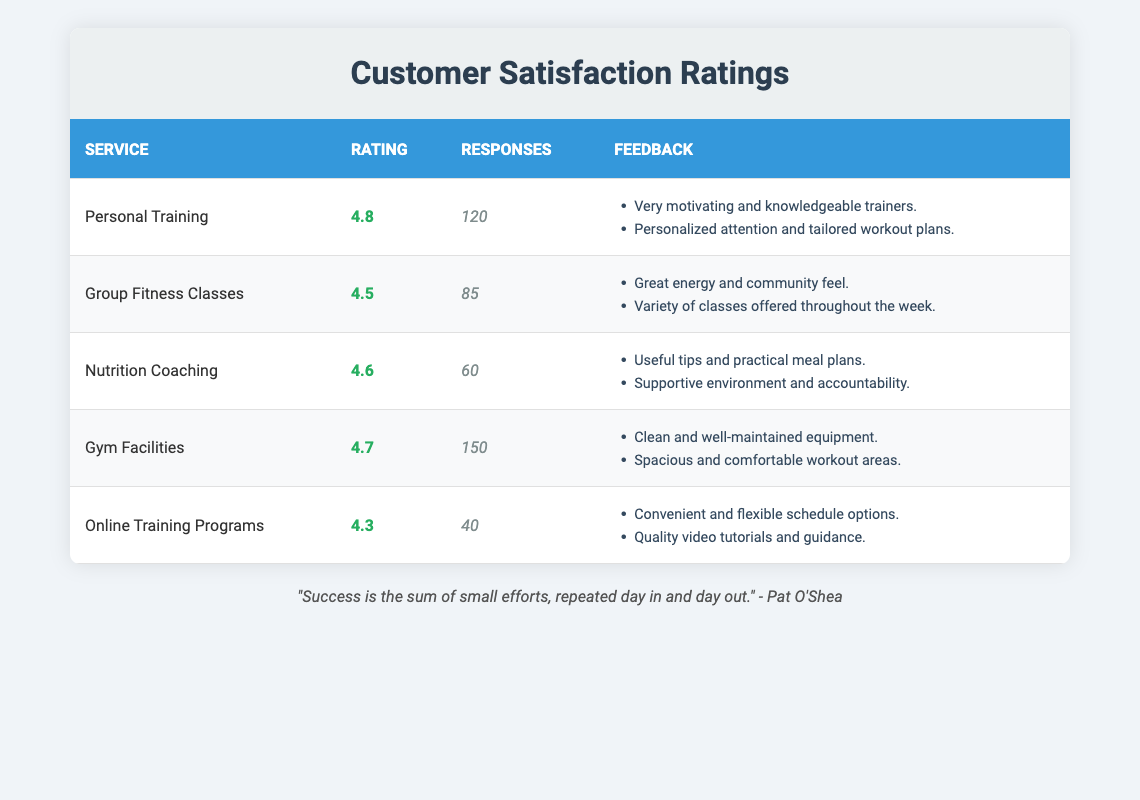What is the highest customer satisfaction rating among the services? By reviewing the ratings column, we see Personal Training with a rating of 4.8 is the highest one listed.
Answer: 4.8 How many responses were received for Group Fitness Classes? Looking at the responses column for Group Fitness Classes, it shows a total of 85 responses were received.
Answer: 85 Are there more responses for Gym Facilities than Personal Training? Gym Facilities received 150 responses while Personal Training received 120 responses. Since 150 is greater than 120, the answer is yes.
Answer: Yes What is the average rating of Nutrition Coaching and Online Training Programs? The rating for Nutrition Coaching is 4.6 and for Online Training Programs is 4.3. Adding these two gives 4.6 + 4.3 = 8.9. Dividing by 2 for the average gives 8.9 / 2 = 4.45.
Answer: 4.45 Did the feedback for Gym Facilities mention anything about equipment? Yes, the feedback for Gym Facilities includes the comment "Clean and well-maintained equipment." thus confirming that it was mentioned.
Answer: Yes How many total responses were received across all services? By summing all the responses: 120 (Personal Training) + 85 (Group Fitness Classes) + 60 (Nutrition Coaching) + 150 (Gym Facilities) + 40 (Online Training Programs) = 455 total responses.
Answer: 455 Which service has the least number of responses? In the responses column, Online Training Programs has the lowest number with only 40 responses compared to the others.
Answer: Online Training Programs What is the difference in ratings between Gym Facilities and Online Training Programs? The rating for Gym Facilities is 4.7 and for Online Training Programs is 4.3. The difference is 4.7 - 4.3 = 0.4.
Answer: 0.4 Does any service have a rating of 4.5 or higher? Yes, Personal Training (4.8), Group Fitness Classes (4.5), Nutrition Coaching (4.6), and Gym Facilities (4.7) all have ratings of 4.5 or higher.
Answer: Yes 